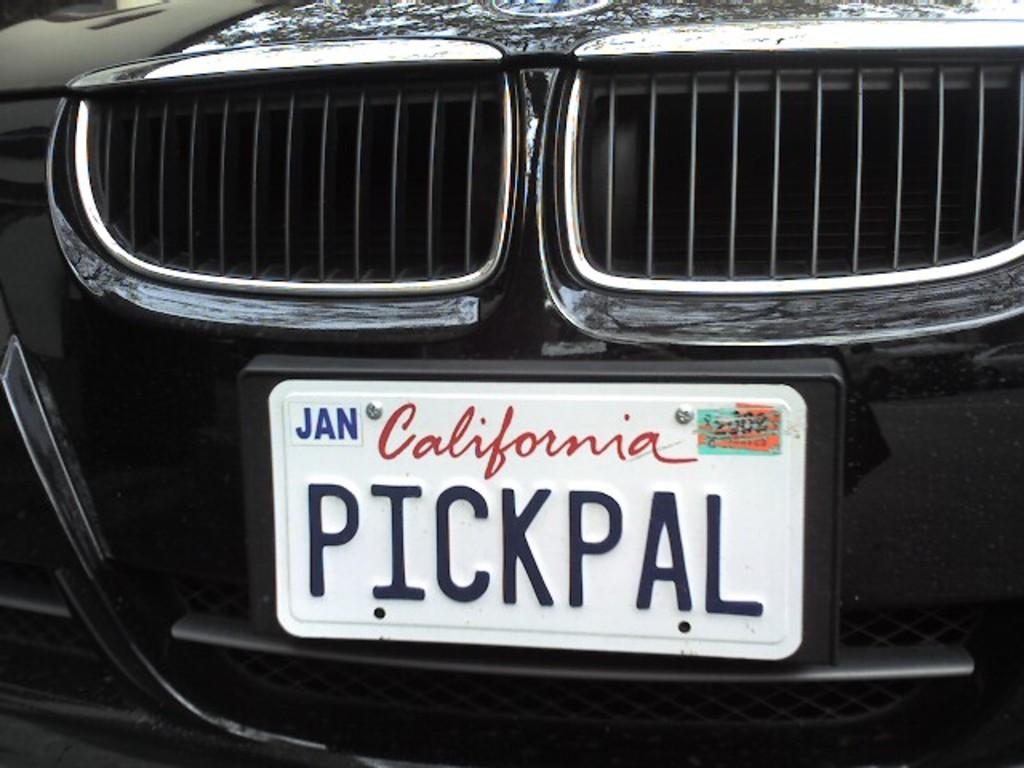What state is the license plate for?
Your answer should be compact. California. What month was the plate issued?
Make the answer very short. January. 